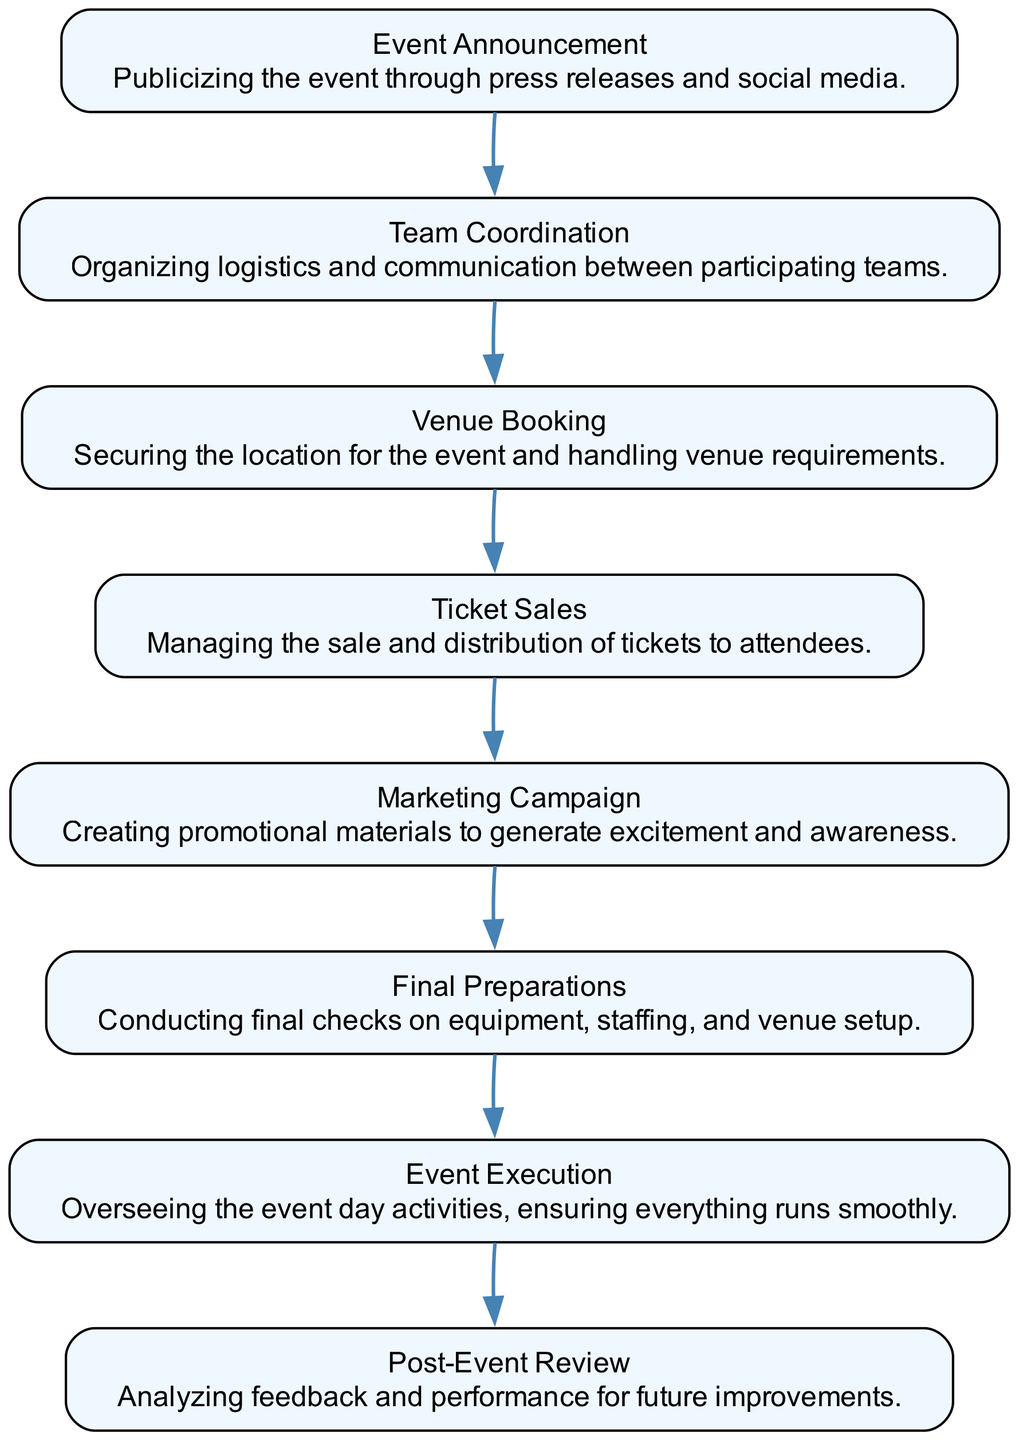What is the first step in the sequence? The first step, according to the diagram, is "Event Announcement". It is the first node listed in the sequence flow from top to bottom.
Answer: Event Announcement How many total steps are depicted in the diagram? The diagram lists eight distinct elements as steps in the sequence, each representing a part of the event planning process.
Answer: Eight What is the last step in the process? The last step in the sequence diagram is "Post-Event Review", which is the final element shown at the end of the flow.
Answer: Post-Event Review Which two steps are directly connected before "Final Preparations"? The steps directly connected before "Final Preparations" are "Ticket Sales" and "Marketing Campaign". They flow sequentially into "Final Preparations".
Answer: Ticket Sales and Marketing Campaign What do "Event Execution" and "Post-Event Review" have in common? Both "Event Execution" and "Post-Event Review" occur at the end of the sequence, marking the conclusion of the event planning and execution process.
Answer: Conclusion of the process How many invisible edges are added for ordering in the diagram? There are seven invisible edges added to ensure proper ordering between the eight nodes in the sequence. The invisible edges connect each consecutive node without visible representation.
Answer: Seven What process step comes immediately after "Venue Booking"? The step that comes immediately after "Venue Booking" is "Ticket Sales". This indicates that securing the venue precedes the management of ticket distribution.
Answer: Ticket Sales Which two elements are responsible for generating excitement and awareness? The two elements responsible for generating excitement and awareness are "Marketing Campaign" and "Event Announcement", as both focus on publicizing the event and creating promotional content.
Answer: Marketing Campaign and Event Announcement 